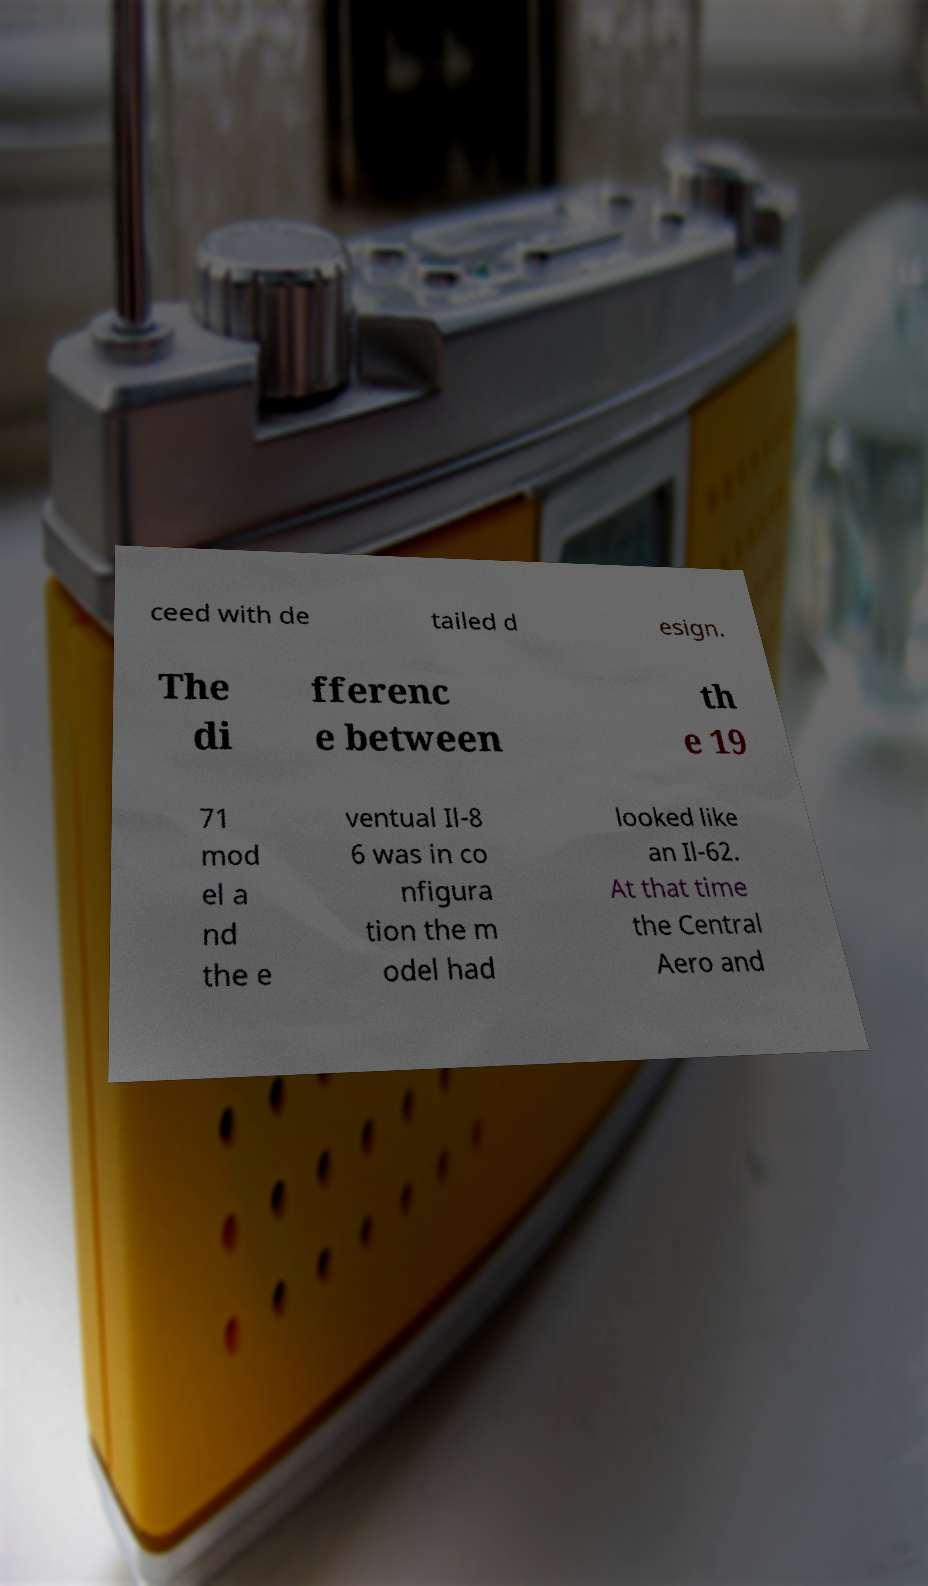Please identify and transcribe the text found in this image. ceed with de tailed d esign. The di fferenc e between th e 19 71 mod el a nd the e ventual Il-8 6 was in co nfigura tion the m odel had looked like an Il-62. At that time the Central Aero and 